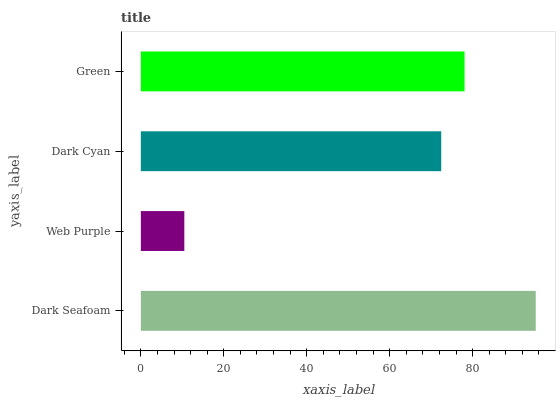Is Web Purple the minimum?
Answer yes or no. Yes. Is Dark Seafoam the maximum?
Answer yes or no. Yes. Is Dark Cyan the minimum?
Answer yes or no. No. Is Dark Cyan the maximum?
Answer yes or no. No. Is Dark Cyan greater than Web Purple?
Answer yes or no. Yes. Is Web Purple less than Dark Cyan?
Answer yes or no. Yes. Is Web Purple greater than Dark Cyan?
Answer yes or no. No. Is Dark Cyan less than Web Purple?
Answer yes or no. No. Is Green the high median?
Answer yes or no. Yes. Is Dark Cyan the low median?
Answer yes or no. Yes. Is Dark Seafoam the high median?
Answer yes or no. No. Is Web Purple the low median?
Answer yes or no. No. 